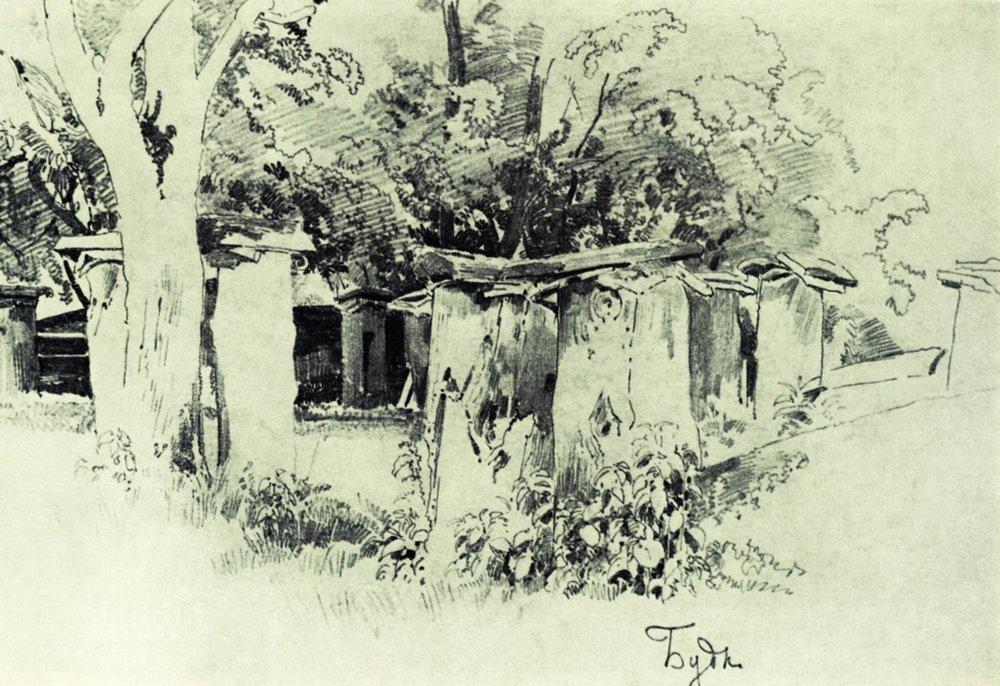What do you see happening in this image? The image depicts a serene rural scene captured in an impressionistic black and white sketch. On the left, we see a cluster of tall trees with branches reaching skyward, creating depth and perspective. Their dark silhouettes stand out dramatically against the lighter background. On the right, a row of small, quaint houses with thatched roofs is nestled, surrounded by lush bushes and shrubs. This evokes a sense of simplicity and tranquility typically associated with rural life. The houses and trees altogether form a harmonious composition that transports the viewer to a bucolic setting. Notably, the artist's signature "Tojin" is subtly inscribed in the bottom right corner, emphasizing the understated elegance of the artwork. The absence of color allows the focus to remain on the textural contrasts and overall composition, enhancing the immersive quality of the scene. 